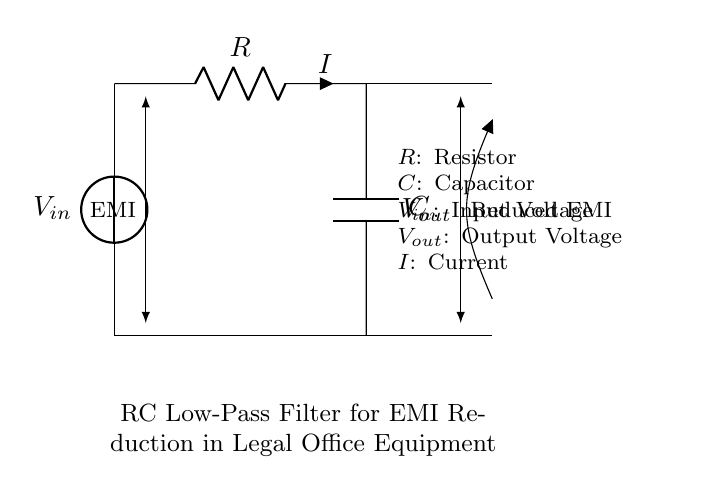What is the purpose of the RC low-pass filter in this design? The purpose is to reduce electromagnetic interference, as indicated by the label in the diagram. It is specifically designed to filter out high-frequency noise while allowing lower-frequency signals to pass through, making it suitable for legal office equipment.
Answer: Reduce electromagnetic interference What components are used in this RC low-pass filter? The circuit diagram shows a resistor and a capacitor connected in series. The labels next to the components confirm their identity, with R representing the resistor and C the capacitor.
Answer: Resistor and capacitor What does Vout represent in the circuit? Vout represents the output voltage across the components, which is taken after the capacitor. This voltage indicates the level of the signal after filtering out higher frequencies.
Answer: Output voltage What is the current labeled in the circuit? The current labeled as I flows through the resistor and capacitor, and is shown in a specified direction in the circuit. This indicates that it is the same current flowing through both components in series.
Answer: Current How does the filter affect the input voltage? The filter reduces the input voltage at the output by attenuating high-frequency components, allowing low-frequency signals to appear at Vout. This is visually confirmed by the arrows indicating reduced EMI from Vout compared to Vin.
Answer: It reduces the input voltage What kind of signals are typically affected by this low-pass filter? This type of low-pass filter primarily affects high-frequency signals, which can include noise and electromagnetic interference, as indicated in the labeled arrows. This makes it effective in improving signal quality for sensitive equipment.
Answer: High-frequency signals 